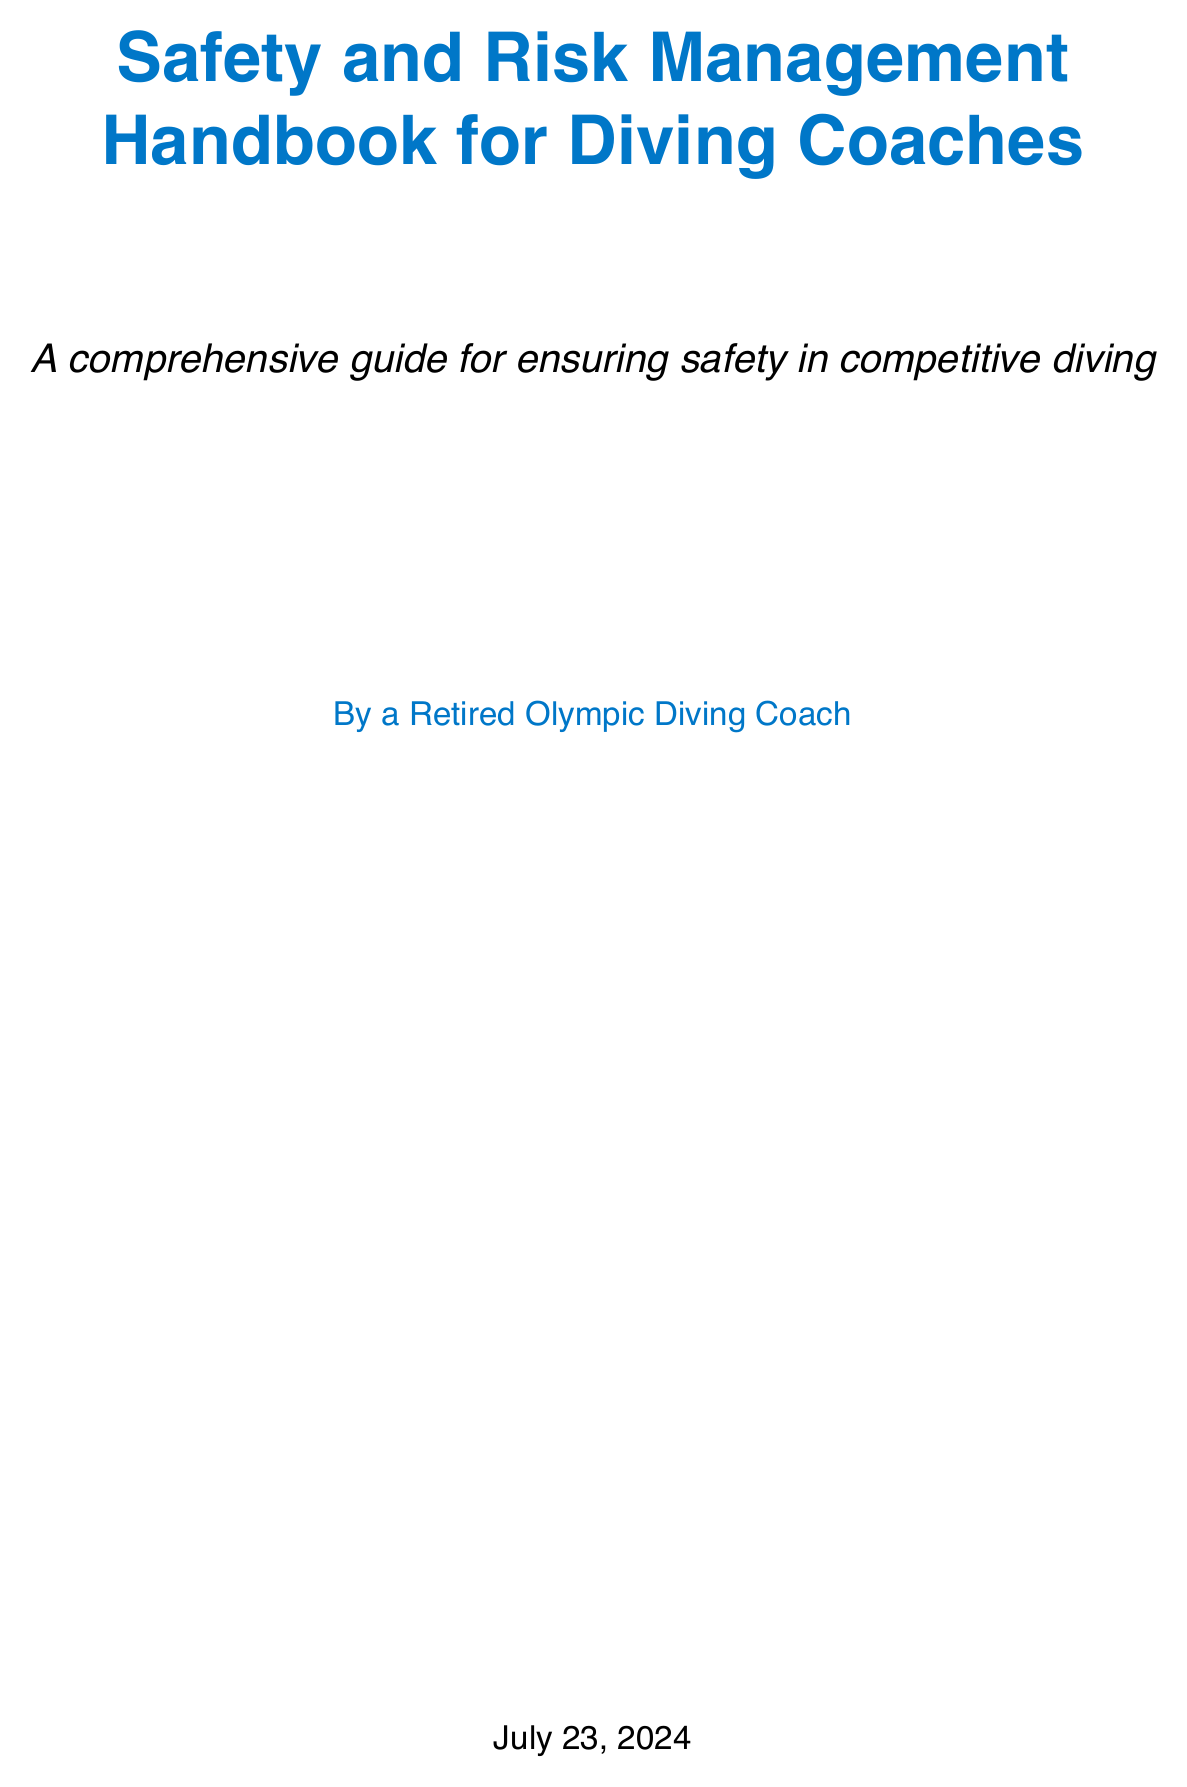What is the title of the handbook? The title is stated at the beginning of the document as "Safety and Risk Management Handbook for Diving Coaches."
Answer: Safety and Risk Management Handbook for Diving Coaches Who is the author of the handbook? The author is mentioned in the author's note, indicating that the author is a retired Olympic diving coach.
Answer: A retired Olympic diving coach What chapter discusses emergency procedures? The chapters are clearly listed, and the one concerning emergency procedures is named "Emergency Procedures."
Answer: Emergency Procedures How many sections are in the "Injury Prevention Strategies" chapter? The document specifies that the "Injury Prevention Strategies" chapter includes five sections.
Answer: Five What is one of the injuries prevention strategies mentioned? The sections contain specific strategies such as "Proper warm-up and cool-down techniques."
Answer: Proper warm-up and cool-down techniques What is required for coaches during emergencies? The manual mentions that coaches need to be CPR and First Aid certified.
Answer: CPR and First Aid certification How often should safety audits be conducted? The text emphasizes the importance of conducting regular safety audits for risk assessment.
Answer: Regularly What does EAP stand for? This abbreviation is introduced in the "Emergency Procedures" section, defining it as "Emergency Action Plan."
Answer: Emergency Action Plan Which case study involves the 2000 Olympics? The "Case Studies and Lessons Learned" chapter references the "2000 Sydney Olympics platform incident."
Answer: 2000 Sydney Olympics platform incident 